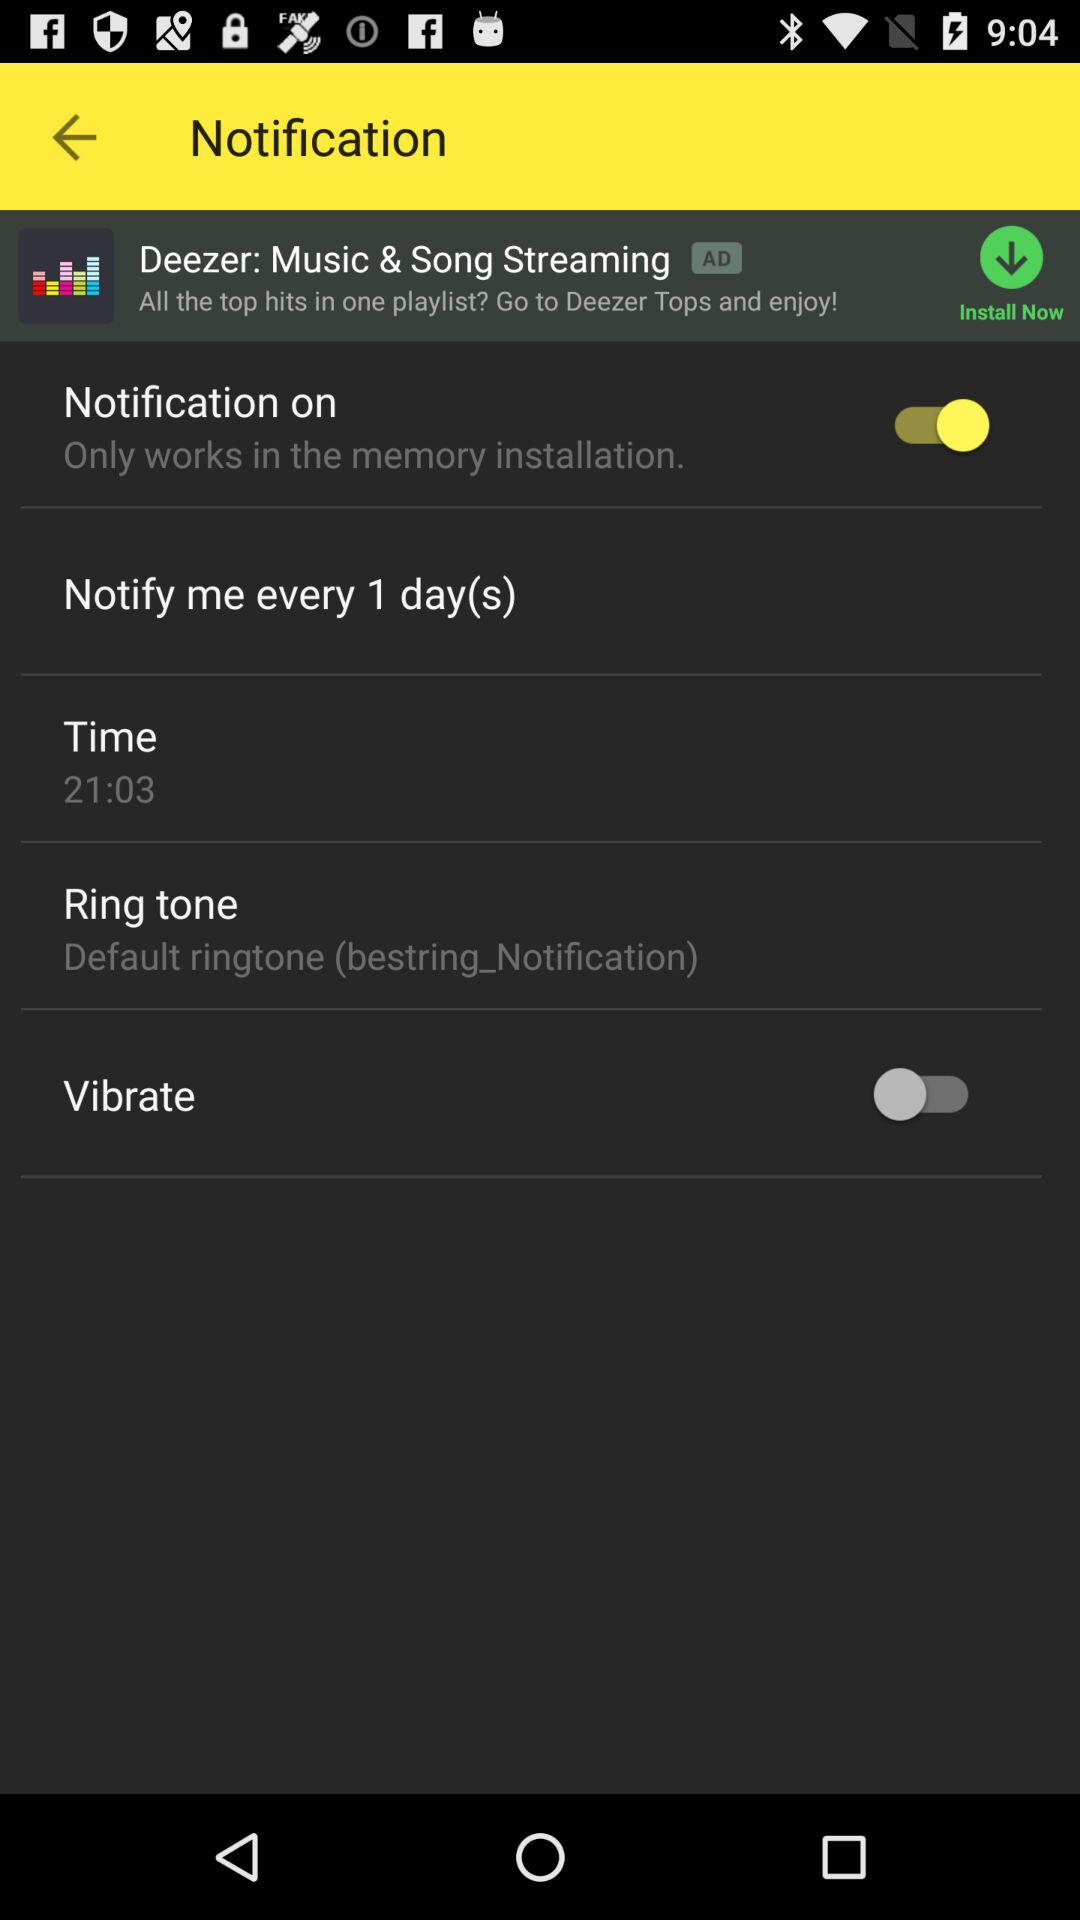In how many days does the notification repeat? The notification repeats every day. 